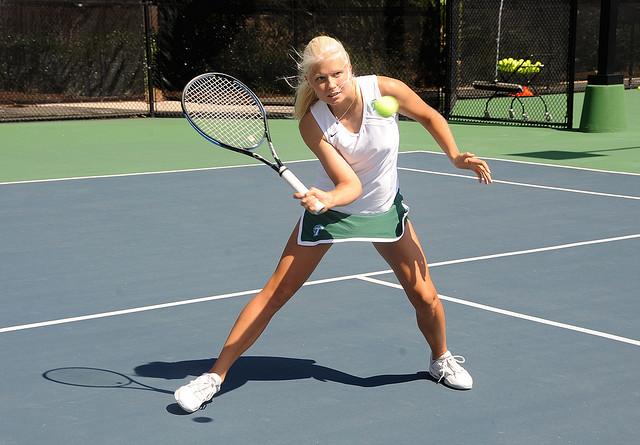What color is the ground?
Write a very short answer. Blue. What sport is being played?
Answer briefly. Tennis. Is the girls right arm in an awkward position?
Give a very brief answer. Yes. 